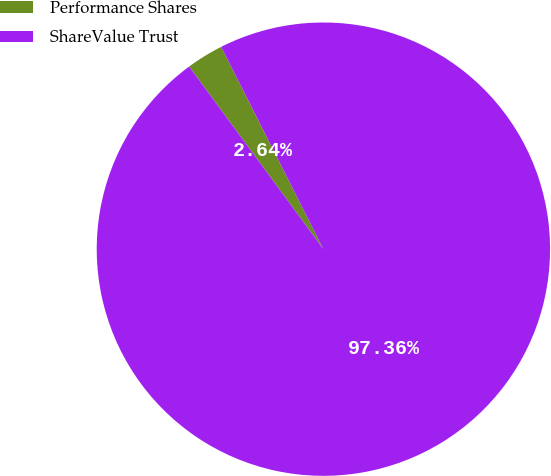Convert chart. <chart><loc_0><loc_0><loc_500><loc_500><pie_chart><fcel>Performance Shares<fcel>ShareValue Trust<nl><fcel>2.64%<fcel>97.36%<nl></chart> 